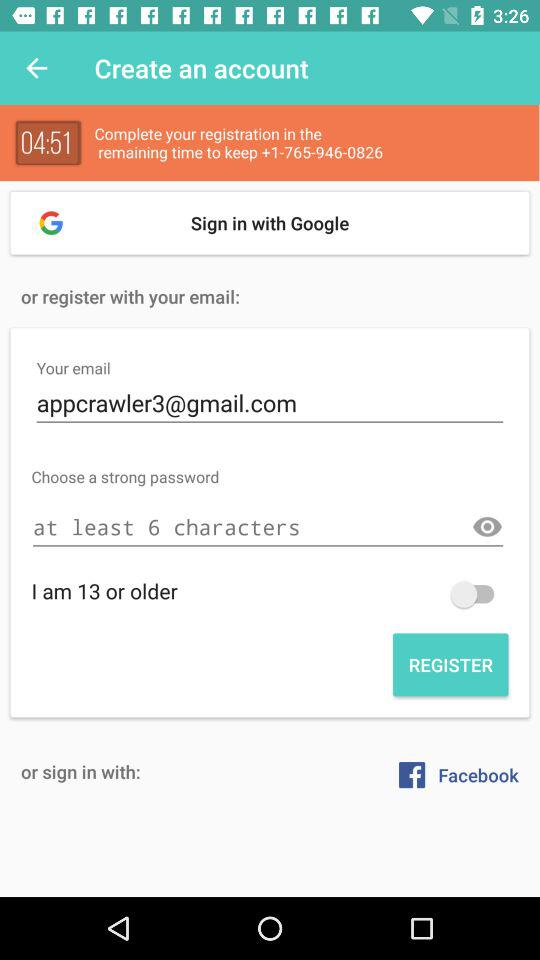Through which application can a user sign in? A user can sign in through "Google" and "Facebook". 